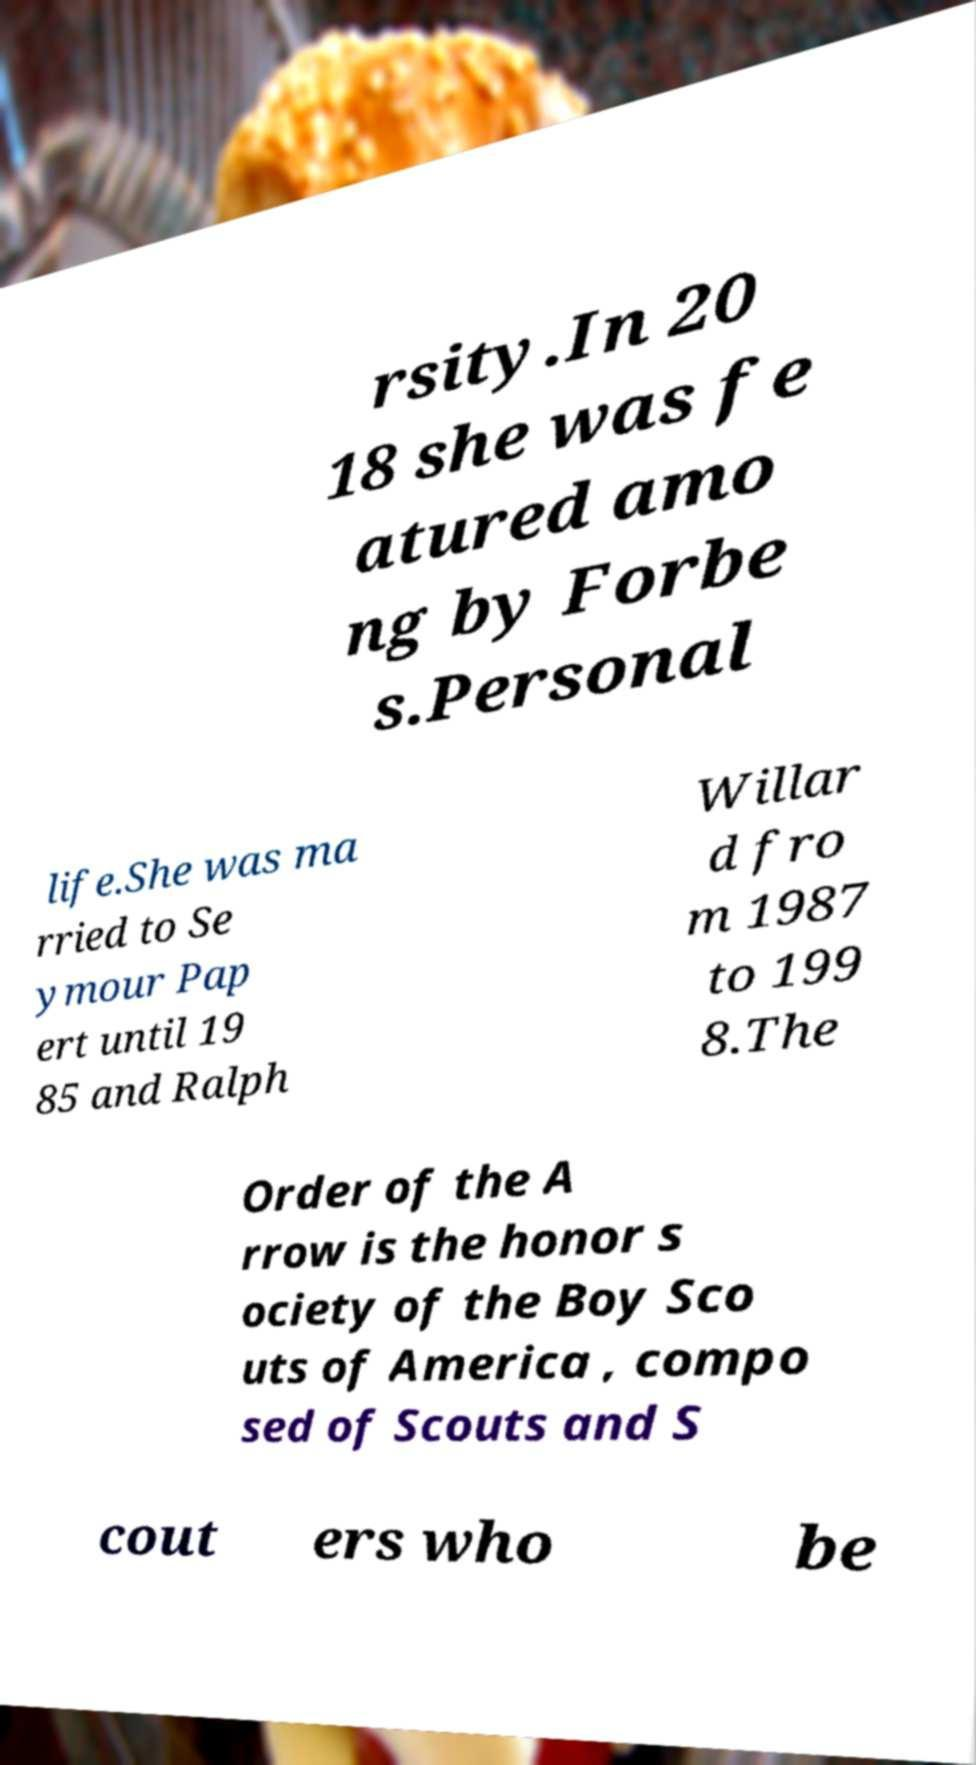There's text embedded in this image that I need extracted. Can you transcribe it verbatim? rsity.In 20 18 she was fe atured amo ng by Forbe s.Personal life.She was ma rried to Se ymour Pap ert until 19 85 and Ralph Willar d fro m 1987 to 199 8.The Order of the A rrow is the honor s ociety of the Boy Sco uts of America , compo sed of Scouts and S cout ers who be 